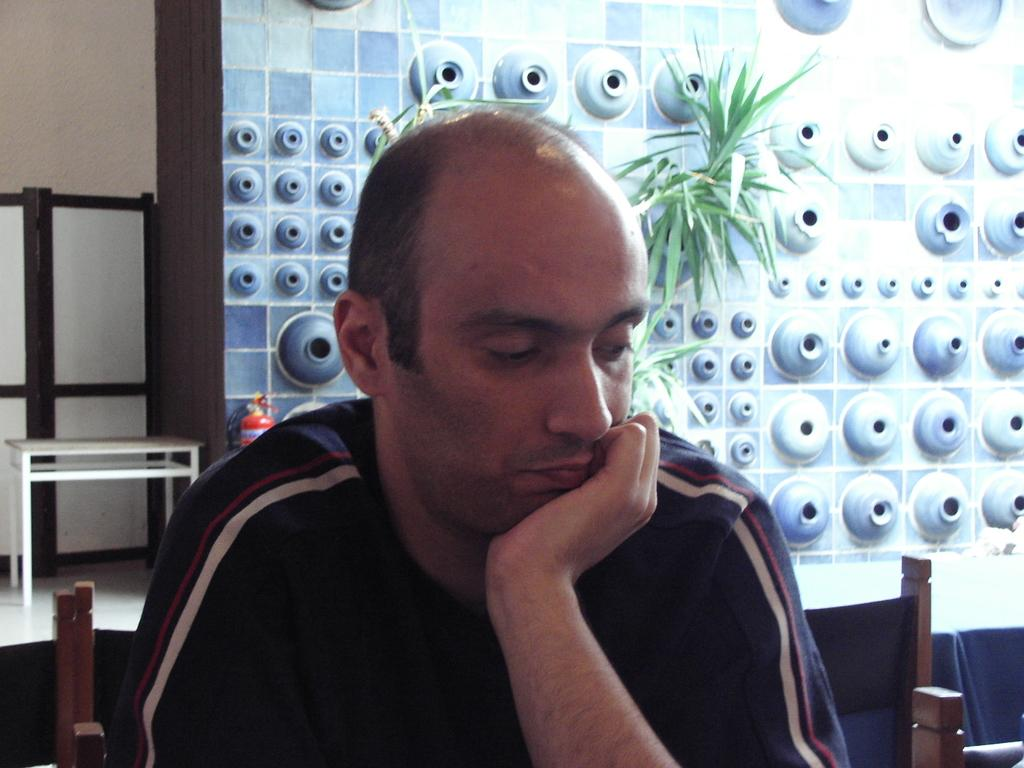What is the man in the image doing? The man is sitting on a chair in the image. What can be seen behind the man? There is a wall behind the man. Can you describe the wall in the image? There is a design on the wall. What type of living organism is present in the image? There is a plant present in the image. What is the man's account number in the image? There is no account number present in the image. How many clocks can be seen on the wall in the image? There are no clocks visible on the wall in the image. 